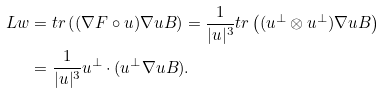<formula> <loc_0><loc_0><loc_500><loc_500>\L L w & = t r \left ( ( \nabla F \circ u ) \nabla u B \right ) = \frac { 1 } { | u | ^ { 3 } } t r \left ( ( u ^ { \perp } \otimes u ^ { \perp } ) \nabla u B \right ) \\ & = \frac { 1 } { | u | ^ { 3 } } u ^ { \perp } \cdot ( u ^ { \perp } \nabla u B ) .</formula> 